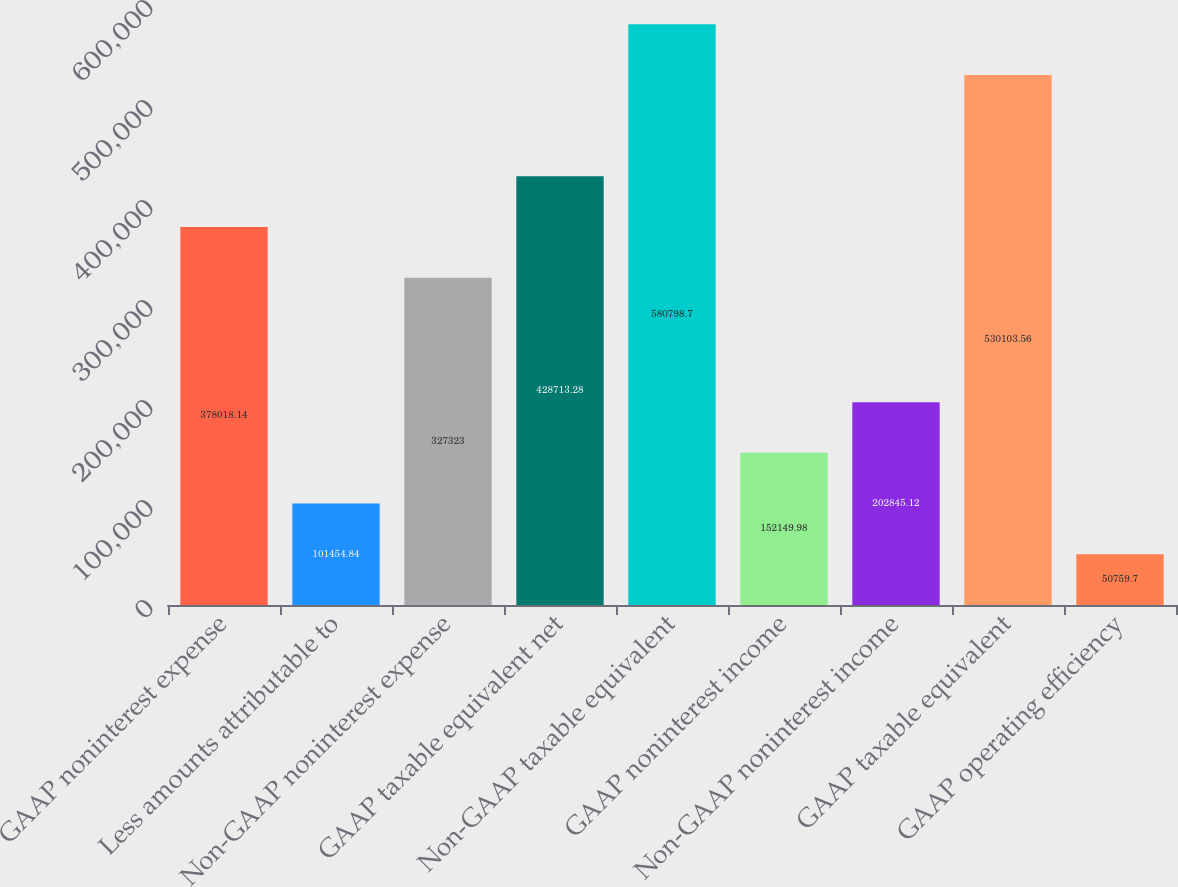<chart> <loc_0><loc_0><loc_500><loc_500><bar_chart><fcel>GAAP noninterest expense<fcel>Less amounts attributable to<fcel>Non-GAAP noninterest expense<fcel>GAAP taxable equivalent net<fcel>Non-GAAP taxable equivalent<fcel>GAAP noninterest income<fcel>Non-GAAP noninterest income<fcel>GAAP taxable equivalent<fcel>GAAP operating efficiency<nl><fcel>378018<fcel>101455<fcel>327323<fcel>428713<fcel>580799<fcel>152150<fcel>202845<fcel>530104<fcel>50759.7<nl></chart> 